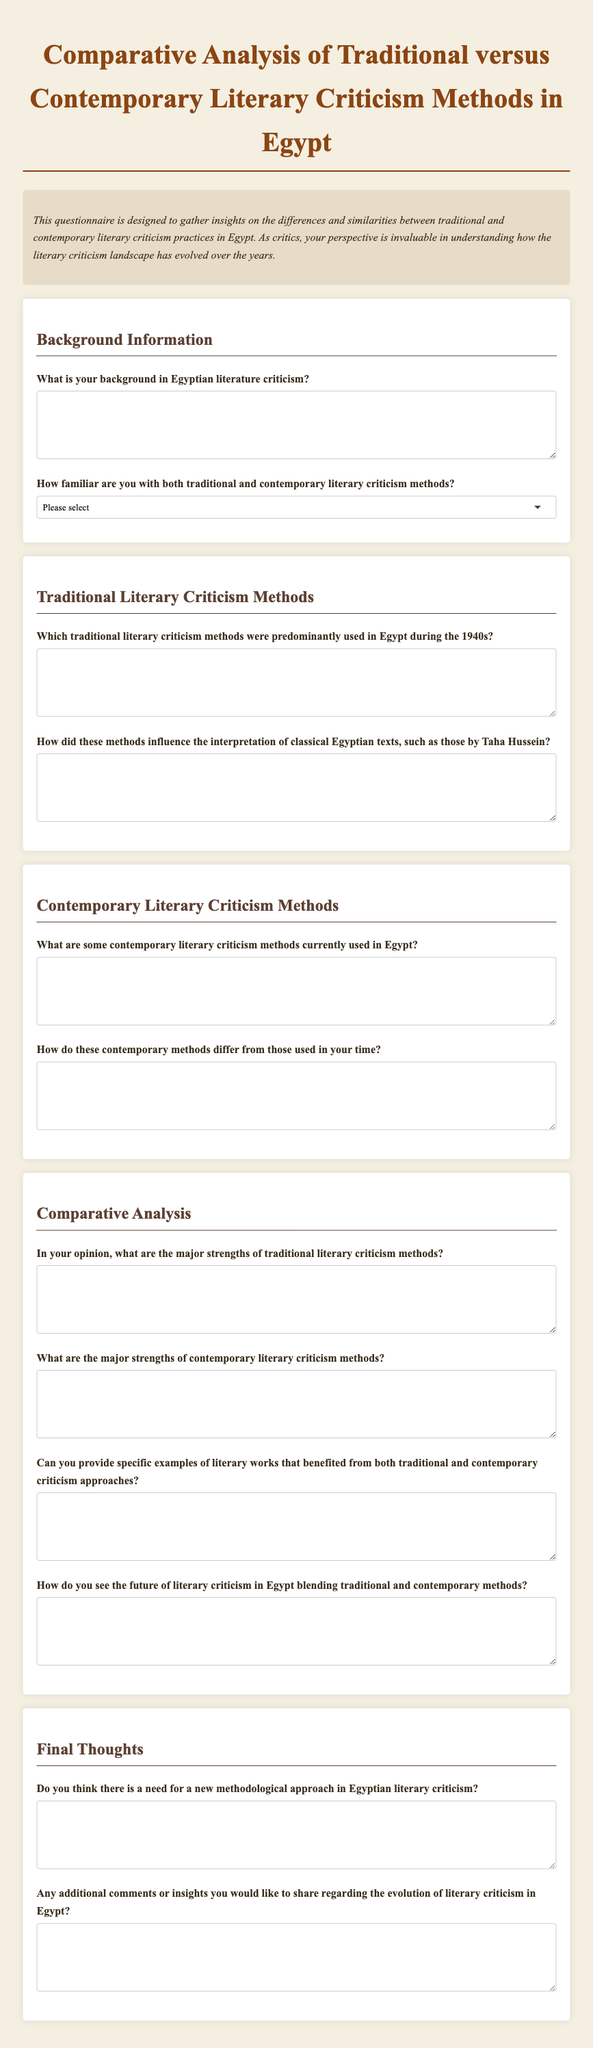What is the title of the questionnaire? The title of the questionnaire is stated prominently at the top of the document.
Answer: Comparative Analysis of Traditional versus Contemporary Literary Criticism Methods in Egypt What is the purpose of this questionnaire? The purpose is provided in the introduction, which describes the intent to gather insights on literary criticism practices.
Answer: To gather insights on the differences and similarities between traditional and contemporary literary criticism practices in Egypt How many sections are there in the questionnaire? The document is organized into distinct categories, which can be counted.
Answer: Four What is asked in the second question of the Traditional Literary Criticism Methods section? The document lists specific inquiries under each section, and the second question can be found in the Traditional Literary Criticism Methods section.
Answer: How did these methods influence the interpretation of classical Egyptian texts, such as those by Taha Hussein? What is the last question in the Final Thoughts section? The structure of the document specifies the final question asked within the last section.
Answer: Any additional comments or insights you would like to share regarding the evolution of literary criticism in Egypt? What is required in the familiarity question? The document specifies the type of response expected for familiarity with literary criticism methods.
Answer: A selection from a dropdown list What distinct features does the document utilize to enhance presentation? The document's structure and styling include various elements designed to improve readability and visual appeal.
Answer: Background color, font style, and section divisions How is the focus of the questionnaire described in the introduction? The introduction summarizes the main aim of the document, highlighting the need for perspectives on criticism methods.
Answer: Understanding how the literary criticism landscape has evolved over the years 